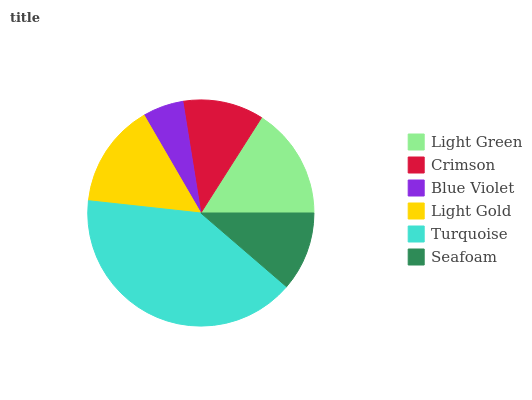Is Blue Violet the minimum?
Answer yes or no. Yes. Is Turquoise the maximum?
Answer yes or no. Yes. Is Crimson the minimum?
Answer yes or no. No. Is Crimson the maximum?
Answer yes or no. No. Is Light Green greater than Crimson?
Answer yes or no. Yes. Is Crimson less than Light Green?
Answer yes or no. Yes. Is Crimson greater than Light Green?
Answer yes or no. No. Is Light Green less than Crimson?
Answer yes or no. No. Is Light Gold the high median?
Answer yes or no. Yes. Is Crimson the low median?
Answer yes or no. Yes. Is Seafoam the high median?
Answer yes or no. No. Is Light Green the low median?
Answer yes or no. No. 